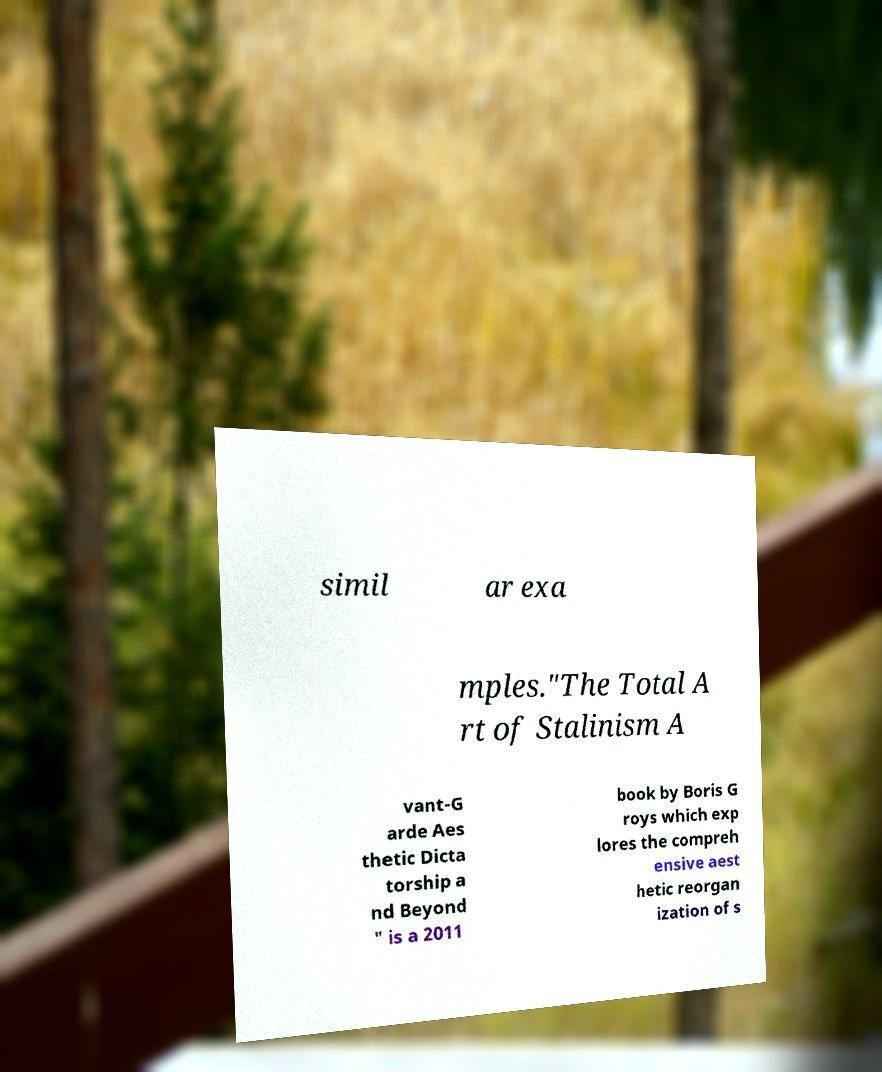Can you accurately transcribe the text from the provided image for me? simil ar exa mples."The Total A rt of Stalinism A vant-G arde Aes thetic Dicta torship a nd Beyond " is a 2011 book by Boris G roys which exp lores the compreh ensive aest hetic reorgan ization of s 